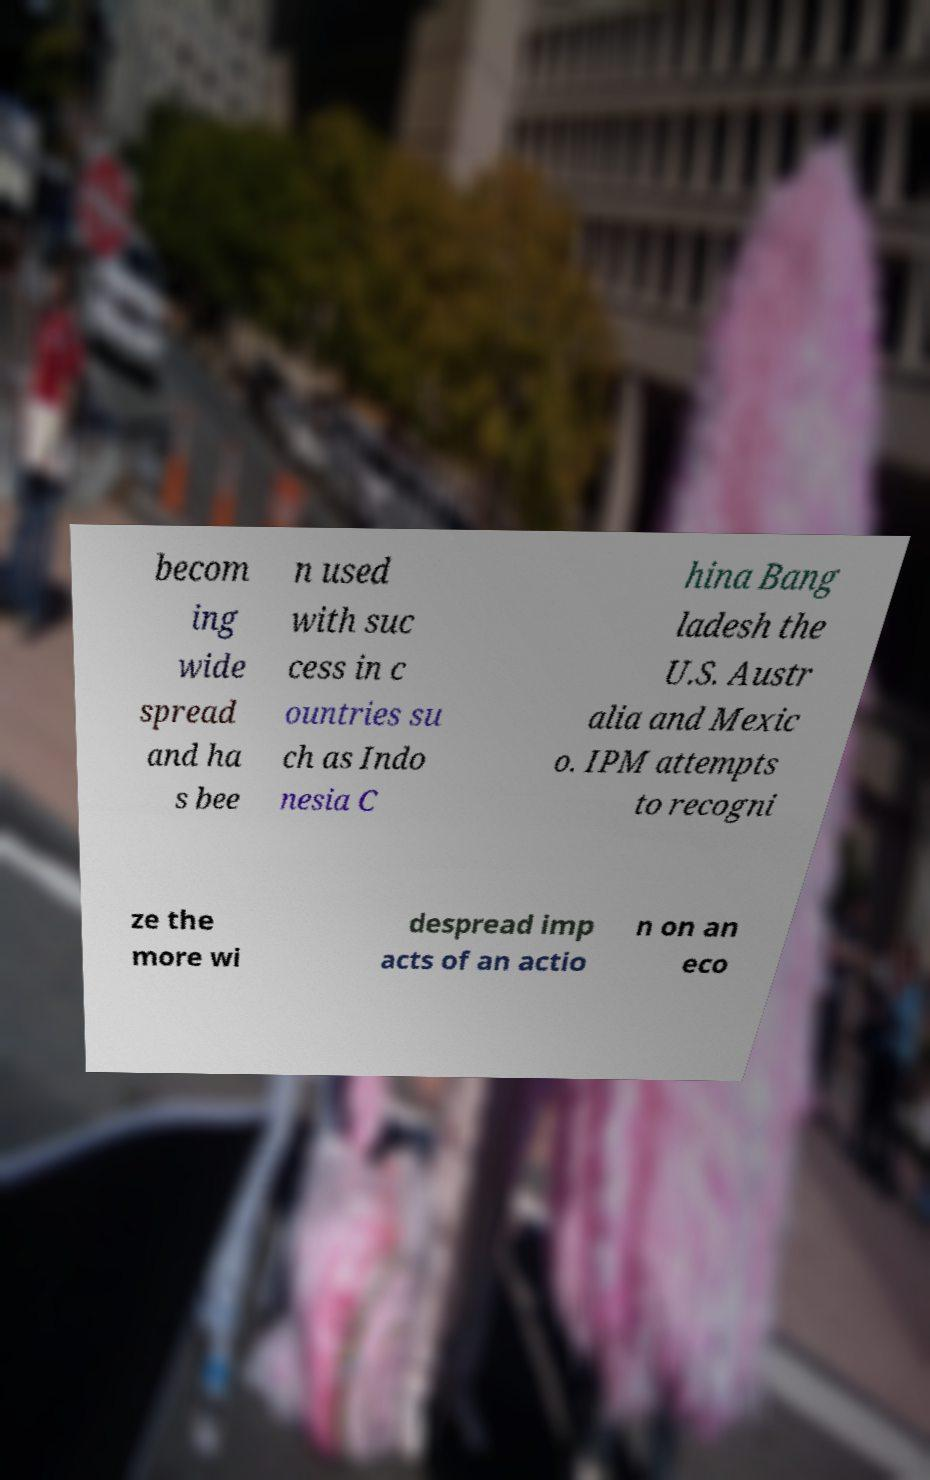What messages or text are displayed in this image? I need them in a readable, typed format. becom ing wide spread and ha s bee n used with suc cess in c ountries su ch as Indo nesia C hina Bang ladesh the U.S. Austr alia and Mexic o. IPM attempts to recogni ze the more wi despread imp acts of an actio n on an eco 